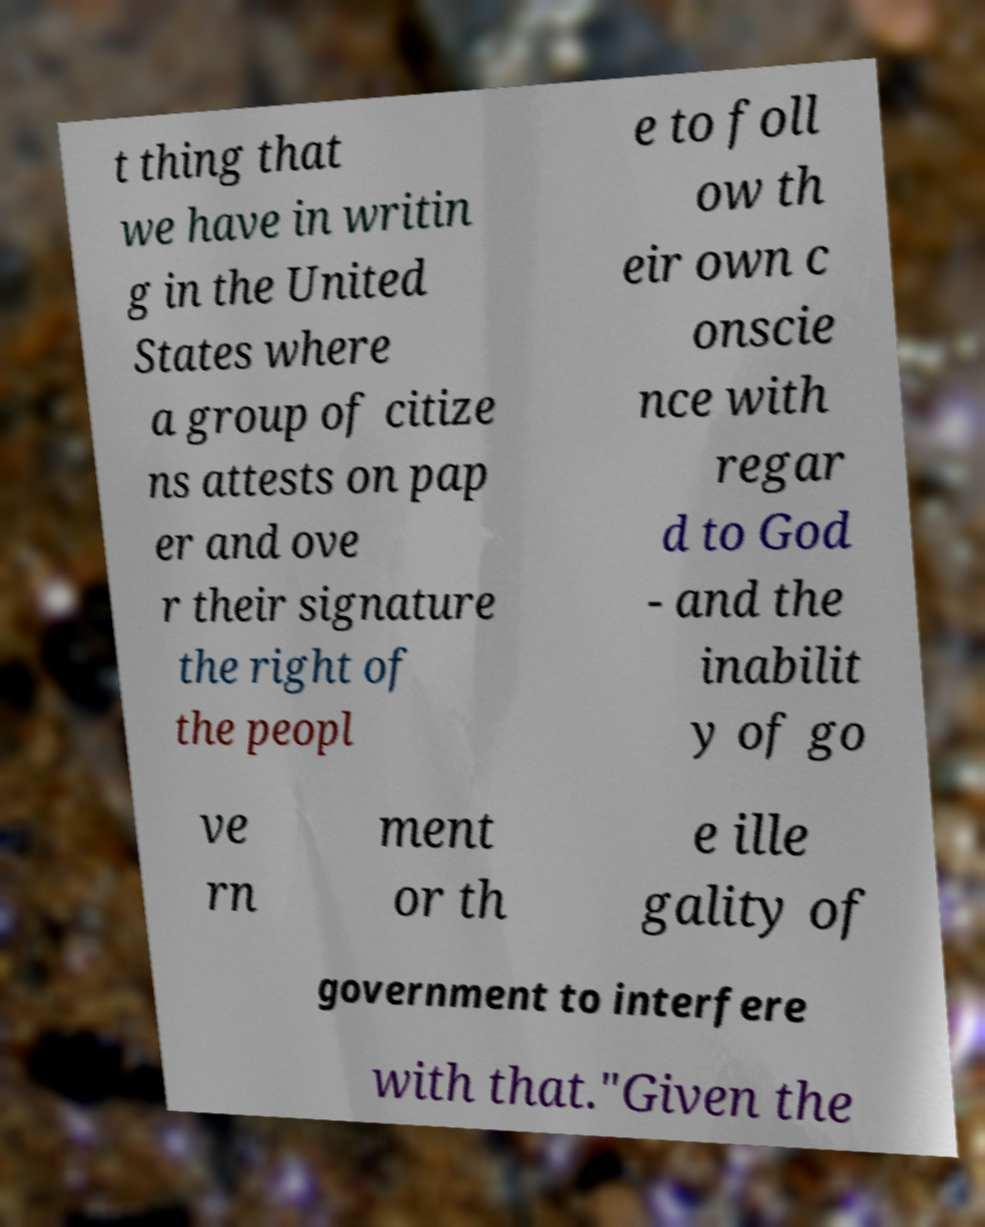Could you extract and type out the text from this image? t thing that we have in writin g in the United States where a group of citize ns attests on pap er and ove r their signature the right of the peopl e to foll ow th eir own c onscie nce with regar d to God - and the inabilit y of go ve rn ment or th e ille gality of government to interfere with that."Given the 